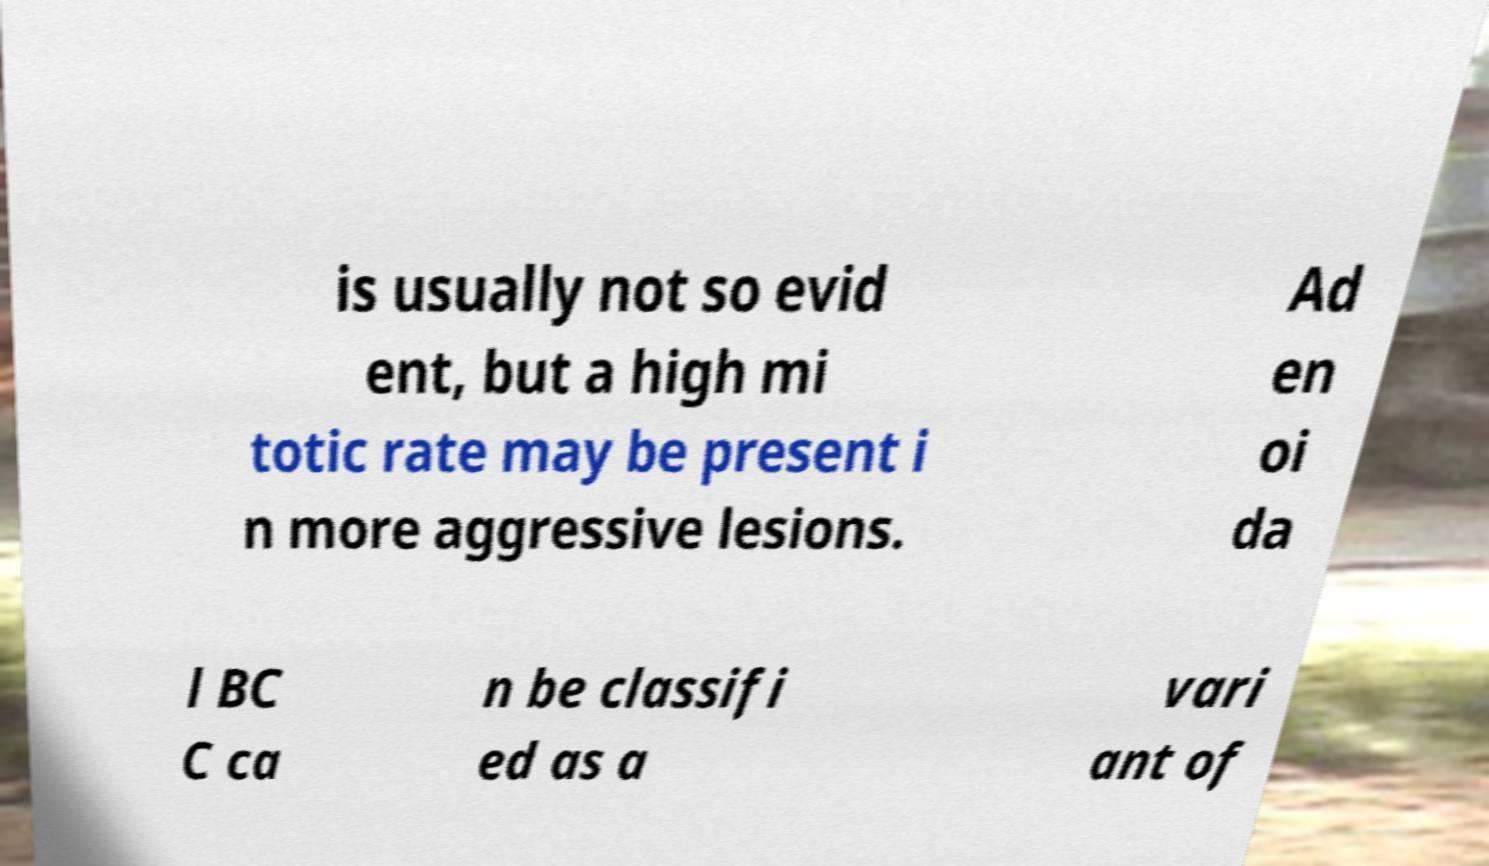Can you accurately transcribe the text from the provided image for me? is usually not so evid ent, but a high mi totic rate may be present i n more aggressive lesions. Ad en oi da l BC C ca n be classifi ed as a vari ant of 